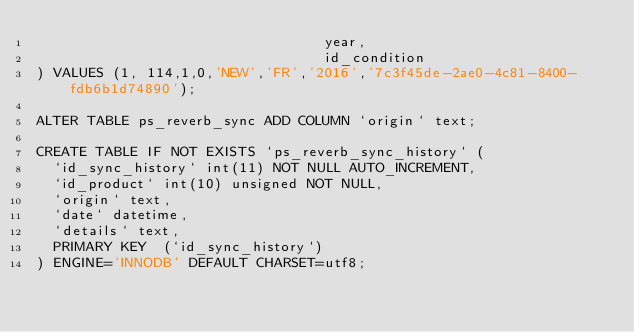<code> <loc_0><loc_0><loc_500><loc_500><_SQL_>                                  year,
                                  id_condition
) VALUES (1, 114,1,0,'NEW','FR','2016','7c3f45de-2ae0-4c81-8400-fdb6b1d74890');

ALTER TABLE ps_reverb_sync ADD COLUMN `origin` text;

CREATE TABLE IF NOT EXISTS `ps_reverb_sync_history` (
  `id_sync_history` int(11) NOT NULL AUTO_INCREMENT,
  `id_product` int(10) unsigned NOT NULL,
  `origin` text,
  `date` datetime,
  `details` text,
  PRIMARY KEY  (`id_sync_history`)
) ENGINE='INNODB' DEFAULT CHARSET=utf8;</code> 